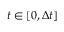Convert formula to latex. <formula><loc_0><loc_0><loc_500><loc_500>t \in [ 0 , \Delta t ]</formula> 